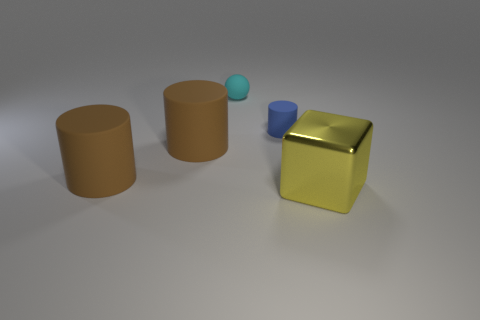Are there any other things that are the same material as the yellow cube?
Your answer should be very brief. No. Is there any other thing that has the same shape as the cyan rubber object?
Provide a succinct answer. No. How many blue matte things are the same size as the cyan object?
Keep it short and to the point. 1. The tiny object that is the same material as the tiny cyan sphere is what color?
Offer a very short reply. Blue. Is the number of big green rubber cubes less than the number of large blocks?
Give a very brief answer. Yes. How many brown things are either large things or small matte cylinders?
Offer a very short reply. 2. What number of things are behind the big yellow metal block and in front of the small cyan sphere?
Provide a succinct answer. 3. Does the small cyan ball have the same material as the blue thing?
Provide a succinct answer. Yes. There is another object that is the same size as the blue matte object; what shape is it?
Offer a terse response. Sphere. Is the number of small purple cylinders greater than the number of blue cylinders?
Provide a succinct answer. No. 